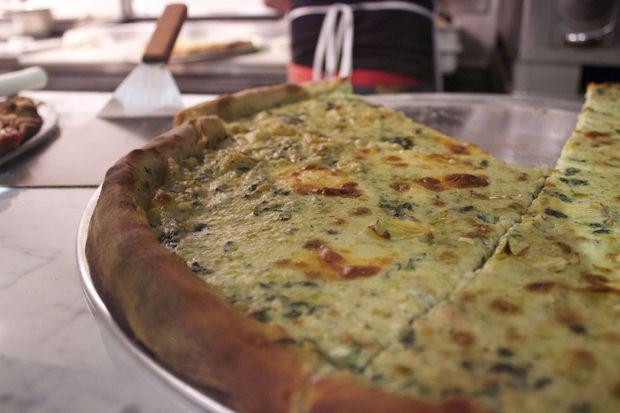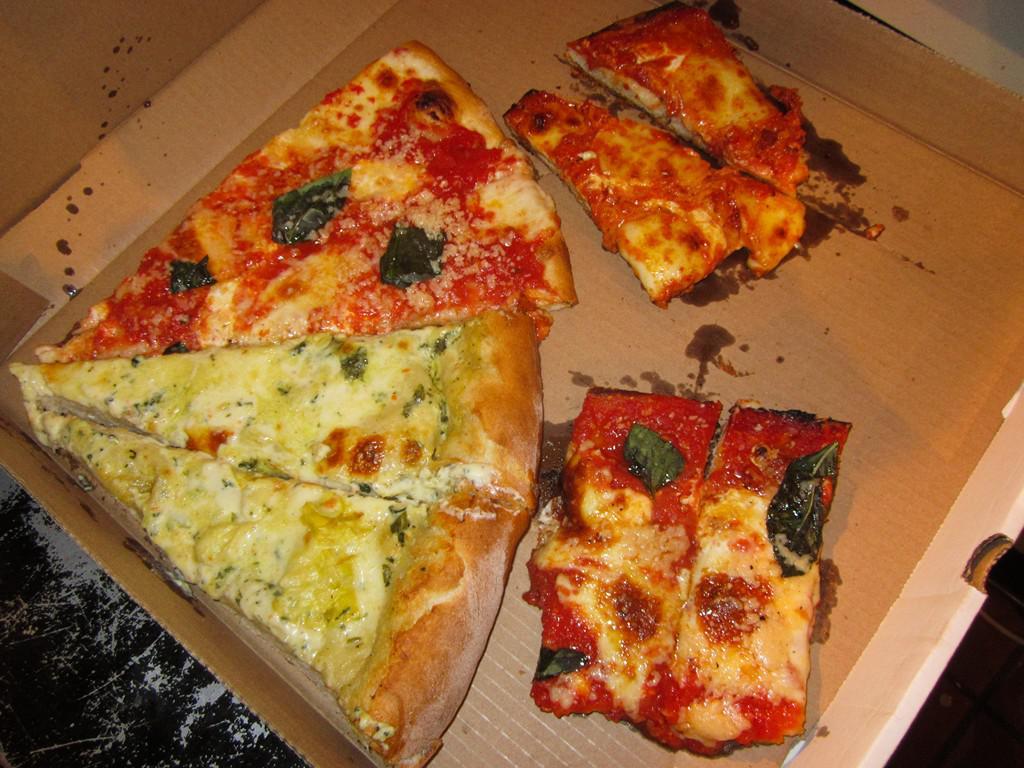The first image is the image on the left, the second image is the image on the right. Considering the images on both sides, is "A person is holding a round-bladed cutting tool over a round pizza in the right image." valid? Answer yes or no. No. 